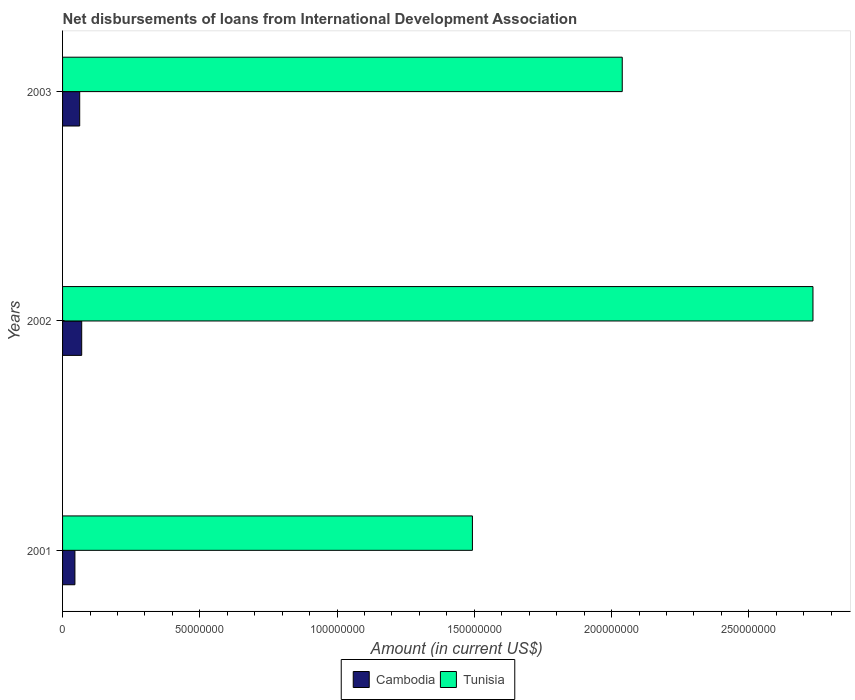How many groups of bars are there?
Offer a very short reply. 3. Are the number of bars per tick equal to the number of legend labels?
Keep it short and to the point. Yes. Are the number of bars on each tick of the Y-axis equal?
Ensure brevity in your answer.  Yes. How many bars are there on the 2nd tick from the top?
Offer a terse response. 2. What is the label of the 1st group of bars from the top?
Make the answer very short. 2003. In how many cases, is the number of bars for a given year not equal to the number of legend labels?
Ensure brevity in your answer.  0. What is the amount of loans disbursed in Cambodia in 2002?
Ensure brevity in your answer.  6.97e+06. Across all years, what is the maximum amount of loans disbursed in Cambodia?
Provide a succinct answer. 6.97e+06. Across all years, what is the minimum amount of loans disbursed in Cambodia?
Your answer should be compact. 4.50e+06. In which year was the amount of loans disbursed in Cambodia maximum?
Provide a succinct answer. 2002. What is the total amount of loans disbursed in Cambodia in the graph?
Your answer should be compact. 1.77e+07. What is the difference between the amount of loans disbursed in Cambodia in 2002 and that in 2003?
Keep it short and to the point. 7.30e+05. What is the difference between the amount of loans disbursed in Tunisia in 2001 and the amount of loans disbursed in Cambodia in 2002?
Give a very brief answer. 1.42e+08. What is the average amount of loans disbursed in Cambodia per year?
Offer a very short reply. 5.91e+06. In the year 2003, what is the difference between the amount of loans disbursed in Tunisia and amount of loans disbursed in Cambodia?
Keep it short and to the point. 1.98e+08. In how many years, is the amount of loans disbursed in Cambodia greater than 170000000 US$?
Provide a succinct answer. 0. What is the ratio of the amount of loans disbursed in Tunisia in 2002 to that in 2003?
Make the answer very short. 1.34. Is the amount of loans disbursed in Cambodia in 2002 less than that in 2003?
Keep it short and to the point. No. What is the difference between the highest and the second highest amount of loans disbursed in Tunisia?
Your answer should be compact. 6.95e+07. What is the difference between the highest and the lowest amount of loans disbursed in Cambodia?
Give a very brief answer. 2.47e+06. What does the 1st bar from the top in 2002 represents?
Your answer should be very brief. Tunisia. What does the 1st bar from the bottom in 2003 represents?
Ensure brevity in your answer.  Cambodia. How many years are there in the graph?
Offer a terse response. 3. What is the difference between two consecutive major ticks on the X-axis?
Give a very brief answer. 5.00e+07. Are the values on the major ticks of X-axis written in scientific E-notation?
Your response must be concise. No. Does the graph contain any zero values?
Provide a short and direct response. No. How many legend labels are there?
Ensure brevity in your answer.  2. What is the title of the graph?
Ensure brevity in your answer.  Net disbursements of loans from International Development Association. Does "Other small states" appear as one of the legend labels in the graph?
Your answer should be compact. No. What is the label or title of the X-axis?
Your answer should be compact. Amount (in current US$). What is the label or title of the Y-axis?
Ensure brevity in your answer.  Years. What is the Amount (in current US$) of Cambodia in 2001?
Your answer should be very brief. 4.50e+06. What is the Amount (in current US$) in Tunisia in 2001?
Make the answer very short. 1.49e+08. What is the Amount (in current US$) in Cambodia in 2002?
Provide a short and direct response. 6.97e+06. What is the Amount (in current US$) in Tunisia in 2002?
Your answer should be compact. 2.73e+08. What is the Amount (in current US$) in Cambodia in 2003?
Your answer should be compact. 6.24e+06. What is the Amount (in current US$) in Tunisia in 2003?
Ensure brevity in your answer.  2.04e+08. Across all years, what is the maximum Amount (in current US$) of Cambodia?
Give a very brief answer. 6.97e+06. Across all years, what is the maximum Amount (in current US$) in Tunisia?
Your answer should be very brief. 2.73e+08. Across all years, what is the minimum Amount (in current US$) of Cambodia?
Your answer should be very brief. 4.50e+06. Across all years, what is the minimum Amount (in current US$) in Tunisia?
Your answer should be very brief. 1.49e+08. What is the total Amount (in current US$) in Cambodia in the graph?
Offer a terse response. 1.77e+07. What is the total Amount (in current US$) in Tunisia in the graph?
Give a very brief answer. 6.27e+08. What is the difference between the Amount (in current US$) of Cambodia in 2001 and that in 2002?
Offer a terse response. -2.47e+06. What is the difference between the Amount (in current US$) of Tunisia in 2001 and that in 2002?
Provide a succinct answer. -1.24e+08. What is the difference between the Amount (in current US$) of Cambodia in 2001 and that in 2003?
Make the answer very short. -1.74e+06. What is the difference between the Amount (in current US$) of Tunisia in 2001 and that in 2003?
Offer a terse response. -5.46e+07. What is the difference between the Amount (in current US$) of Cambodia in 2002 and that in 2003?
Ensure brevity in your answer.  7.30e+05. What is the difference between the Amount (in current US$) of Tunisia in 2002 and that in 2003?
Keep it short and to the point. 6.95e+07. What is the difference between the Amount (in current US$) of Cambodia in 2001 and the Amount (in current US$) of Tunisia in 2002?
Ensure brevity in your answer.  -2.69e+08. What is the difference between the Amount (in current US$) of Cambodia in 2001 and the Amount (in current US$) of Tunisia in 2003?
Your response must be concise. -1.99e+08. What is the difference between the Amount (in current US$) in Cambodia in 2002 and the Amount (in current US$) in Tunisia in 2003?
Your answer should be compact. -1.97e+08. What is the average Amount (in current US$) in Cambodia per year?
Provide a succinct answer. 5.91e+06. What is the average Amount (in current US$) of Tunisia per year?
Make the answer very short. 2.09e+08. In the year 2001, what is the difference between the Amount (in current US$) of Cambodia and Amount (in current US$) of Tunisia?
Give a very brief answer. -1.45e+08. In the year 2002, what is the difference between the Amount (in current US$) of Cambodia and Amount (in current US$) of Tunisia?
Your answer should be compact. -2.66e+08. In the year 2003, what is the difference between the Amount (in current US$) in Cambodia and Amount (in current US$) in Tunisia?
Ensure brevity in your answer.  -1.98e+08. What is the ratio of the Amount (in current US$) in Cambodia in 2001 to that in 2002?
Provide a succinct answer. 0.65. What is the ratio of the Amount (in current US$) in Tunisia in 2001 to that in 2002?
Your answer should be very brief. 0.55. What is the ratio of the Amount (in current US$) in Cambodia in 2001 to that in 2003?
Offer a terse response. 0.72. What is the ratio of the Amount (in current US$) of Tunisia in 2001 to that in 2003?
Give a very brief answer. 0.73. What is the ratio of the Amount (in current US$) in Cambodia in 2002 to that in 2003?
Provide a short and direct response. 1.12. What is the ratio of the Amount (in current US$) in Tunisia in 2002 to that in 2003?
Offer a terse response. 1.34. What is the difference between the highest and the second highest Amount (in current US$) of Cambodia?
Make the answer very short. 7.30e+05. What is the difference between the highest and the second highest Amount (in current US$) in Tunisia?
Offer a terse response. 6.95e+07. What is the difference between the highest and the lowest Amount (in current US$) of Cambodia?
Provide a short and direct response. 2.47e+06. What is the difference between the highest and the lowest Amount (in current US$) of Tunisia?
Keep it short and to the point. 1.24e+08. 